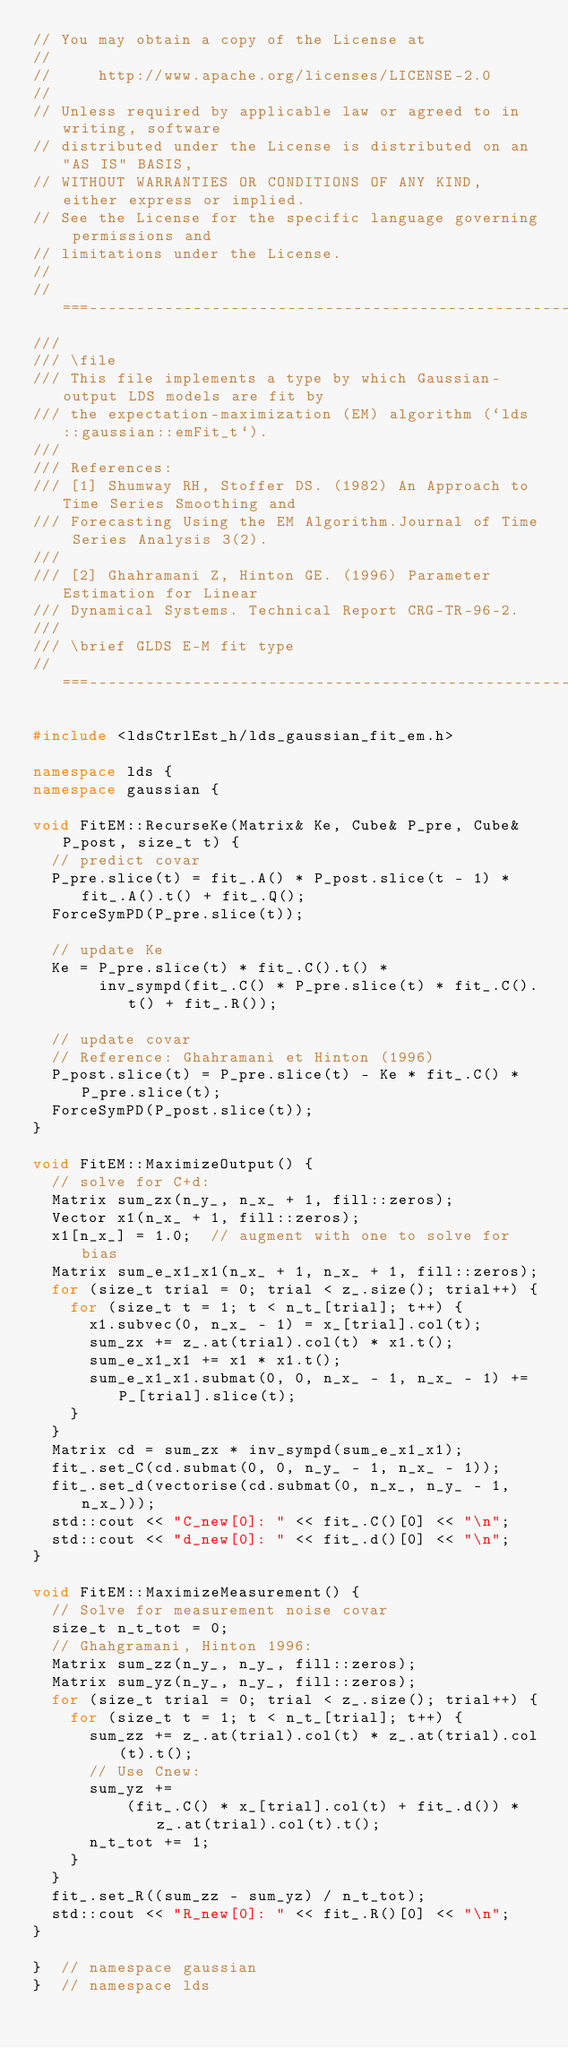<code> <loc_0><loc_0><loc_500><loc_500><_C++_>// You may obtain a copy of the License at
//
//     http://www.apache.org/licenses/LICENSE-2.0
//
// Unless required by applicable law or agreed to in writing, software
// distributed under the License is distributed on an "AS IS" BASIS,
// WITHOUT WARRANTIES OR CONDITIONS OF ANY KIND, either express or implied.
// See the License for the specific language governing permissions and
// limitations under the License.
//
//===----------------------------------------------------------------------===//
///
/// \file
/// This file implements a type by which Gaussian-output LDS models are fit by
/// the expectation-maximization (EM) algorithm (`lds::gaussian::emFit_t`).
///
/// References:
/// [1] Shumway RH, Stoffer DS. (1982) An Approach to Time Series Smoothing and
/// Forecasting Using the EM Algorithm.Journal of Time Series Analysis 3(2).
///
/// [2] Ghahramani Z, Hinton GE. (1996) Parameter Estimation for Linear
/// Dynamical Systems. Technical Report CRG-TR-96-2.
///
/// \brief GLDS E-M fit type
//===----------------------------------------------------------------------===//

#include <ldsCtrlEst_h/lds_gaussian_fit_em.h>

namespace lds {
namespace gaussian {

void FitEM::RecurseKe(Matrix& Ke, Cube& P_pre, Cube& P_post, size_t t) {
  // predict covar
  P_pre.slice(t) = fit_.A() * P_post.slice(t - 1) * fit_.A().t() + fit_.Q();
  ForceSymPD(P_pre.slice(t));

  // update Ke
  Ke = P_pre.slice(t) * fit_.C().t() *
       inv_sympd(fit_.C() * P_pre.slice(t) * fit_.C().t() + fit_.R());

  // update covar
  // Reference: Ghahramani et Hinton (1996)
  P_post.slice(t) = P_pre.slice(t) - Ke * fit_.C() * P_pre.slice(t);
  ForceSymPD(P_post.slice(t));
}

void FitEM::MaximizeOutput() {
  // solve for C+d:
  Matrix sum_zx(n_y_, n_x_ + 1, fill::zeros);
  Vector x1(n_x_ + 1, fill::zeros);
  x1[n_x_] = 1.0;  // augment with one to solve for bias
  Matrix sum_e_x1_x1(n_x_ + 1, n_x_ + 1, fill::zeros);
  for (size_t trial = 0; trial < z_.size(); trial++) {
    for (size_t t = 1; t < n_t_[trial]; t++) {
      x1.subvec(0, n_x_ - 1) = x_[trial].col(t);
      sum_zx += z_.at(trial).col(t) * x1.t();
      sum_e_x1_x1 += x1 * x1.t();
      sum_e_x1_x1.submat(0, 0, n_x_ - 1, n_x_ - 1) += P_[trial].slice(t);
    }
  }
  Matrix cd = sum_zx * inv_sympd(sum_e_x1_x1);
  fit_.set_C(cd.submat(0, 0, n_y_ - 1, n_x_ - 1));
  fit_.set_d(vectorise(cd.submat(0, n_x_, n_y_ - 1, n_x_)));
  std::cout << "C_new[0]: " << fit_.C()[0] << "\n";
  std::cout << "d_new[0]: " << fit_.d()[0] << "\n";
}

void FitEM::MaximizeMeasurement() {
  // Solve for measurement noise covar
  size_t n_t_tot = 0;
  // Ghahgramani, Hinton 1996:
  Matrix sum_zz(n_y_, n_y_, fill::zeros);
  Matrix sum_yz(n_y_, n_y_, fill::zeros);
  for (size_t trial = 0; trial < z_.size(); trial++) {
    for (size_t t = 1; t < n_t_[trial]; t++) {
      sum_zz += z_.at(trial).col(t) * z_.at(trial).col(t).t();
      // Use Cnew:
      sum_yz +=
          (fit_.C() * x_[trial].col(t) + fit_.d()) * z_.at(trial).col(t).t();
      n_t_tot += 1;
    }
  }
  fit_.set_R((sum_zz - sum_yz) / n_t_tot);
  std::cout << "R_new[0]: " << fit_.R()[0] << "\n";
}

}  // namespace gaussian
}  // namespace lds
</code> 